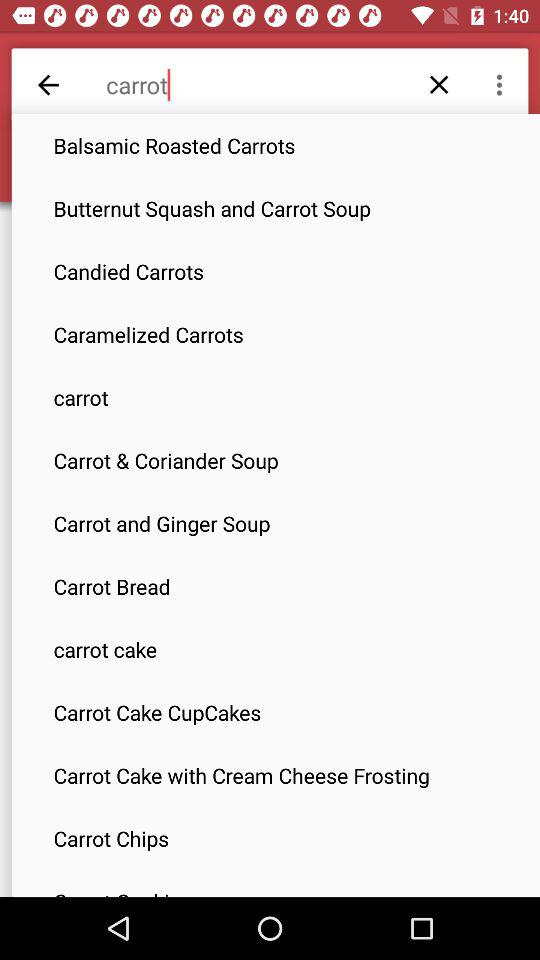What is written in the search option? The option that is written in the search is carrot. 